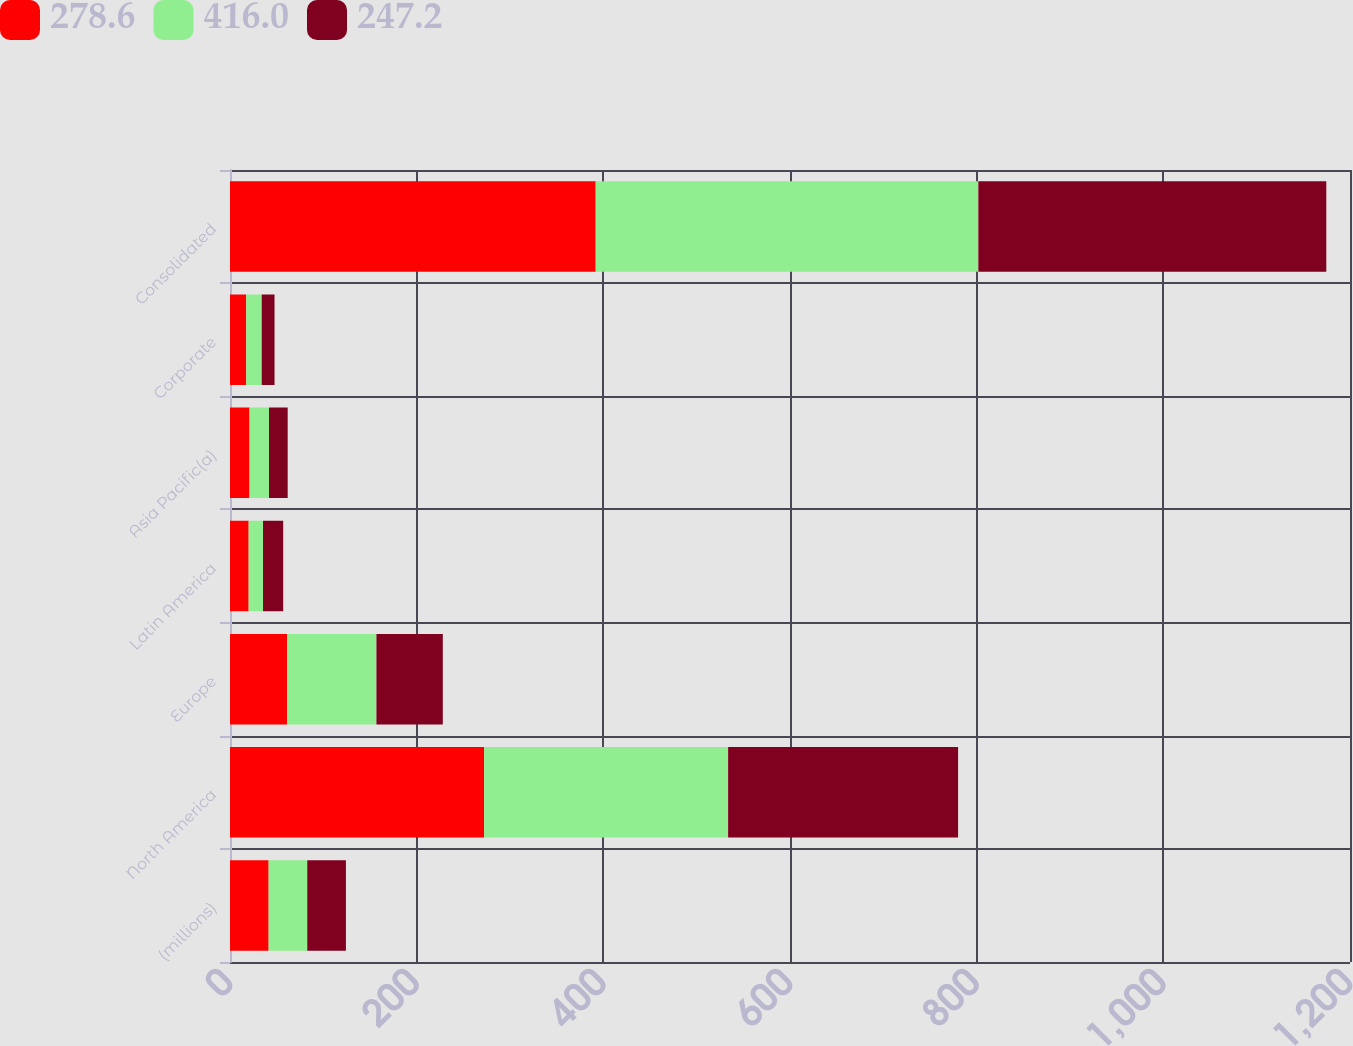<chart> <loc_0><loc_0><loc_500><loc_500><stacked_bar_chart><ecel><fcel>(millions)<fcel>North America<fcel>Europe<fcel>Latin America<fcel>Asia Pacific(a)<fcel>Corporate<fcel>Consolidated<nl><fcel>278.6<fcel>41.4<fcel>272.3<fcel>61.2<fcel>20<fcel>20.9<fcel>17.4<fcel>391.8<nl><fcel>416<fcel>41.4<fcel>261.4<fcel>95.7<fcel>15.4<fcel>20.9<fcel>16.6<fcel>410<nl><fcel>247.2<fcel>41.4<fcel>246.4<fcel>71.1<fcel>21.6<fcel>20<fcel>13.7<fcel>372.8<nl></chart> 